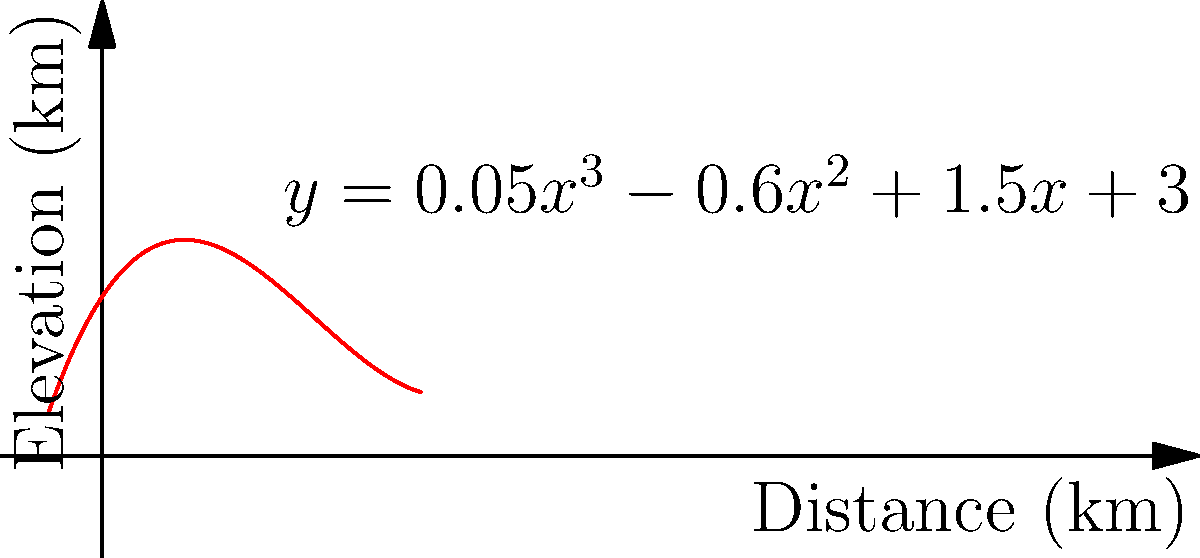As a Ukrainian hiker, you're studying the profile of a mountain range in the Carpathians. The elevation of the range can be modeled by the function $f(x) = 0.05x^3 - 0.6x^2 + 1.5x + 3$, where $x$ is the distance in kilometers from the starting point of your hike, and $f(x)$ is the elevation in kilometers. At what distance from the starting point does the mountain range reach its lowest elevation within the first 6 kilometers of your hike? To find the lowest point of the mountain range within the first 6 kilometers, we need to follow these steps:

1) The lowest point will occur where the derivative of the function is zero. Let's find the derivative:
   $f'(x) = 0.15x^2 - 1.2x + 1.5$

2) Set the derivative equal to zero and solve for x:
   $0.15x^2 - 1.2x + 1.5 = 0$

3) This is a quadratic equation. We can solve it using the quadratic formula:
   $x = \frac{-b \pm \sqrt{b^2 - 4ac}}{2a}$

   Where $a = 0.15$, $b = -1.2$, and $c = 1.5$

4) Plugging in these values:
   $x = \frac{1.2 \pm \sqrt{(-1.2)^2 - 4(0.15)(1.5)}}{2(0.15)}$

5) Simplifying:
   $x = \frac{1.2 \pm \sqrt{1.44 - 0.9}}{0.3} = \frac{1.2 \pm \sqrt{0.54}}{0.3} = \frac{1.2 \pm 0.735}{0.3}$

6) This gives us two solutions:
   $x_1 = \frac{1.2 + 0.735}{0.3} = 6.45$
   $x_2 = \frac{1.2 - 0.735}{0.3} = 1.55$

7) Since we're only interested in the first 6 kilometers, $x_2 = 1.55$ is our solution.

Therefore, the mountain range reaches its lowest elevation at approximately 1.55 kilometers from the starting point of the hike.
Answer: 1.55 km 